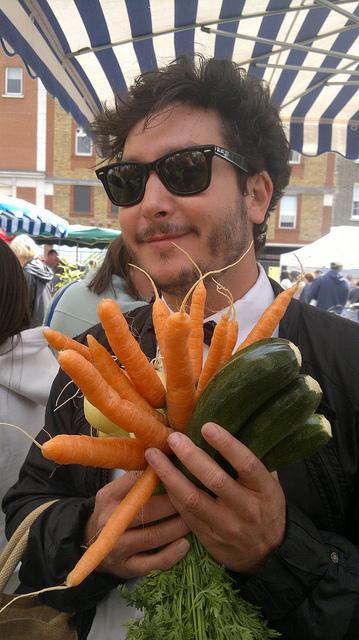What kind of green vegetable is held underneath of the carrots like a card? cucumber 